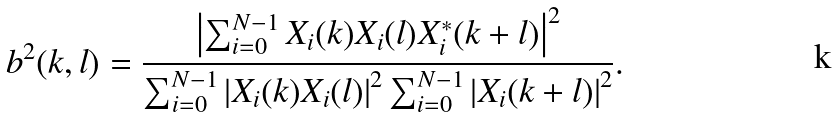<formula> <loc_0><loc_0><loc_500><loc_500>b ^ { 2 } ( k , l ) = \frac { \left | \sum _ { i = 0 } ^ { N - 1 } { X _ { i } ( k ) X _ { i } ( l ) X ^ { * } _ { i } ( k + l ) } \right | ^ { 2 } } { \sum _ { i = 0 } ^ { N - 1 } { \left | X _ { i } ( k ) X _ { i } ( l ) \right | ^ { 2 } } \sum _ { i = 0 } ^ { N - 1 } { \left | X _ { i } ( k + l ) \right | ^ { 2 } } } .</formula> 